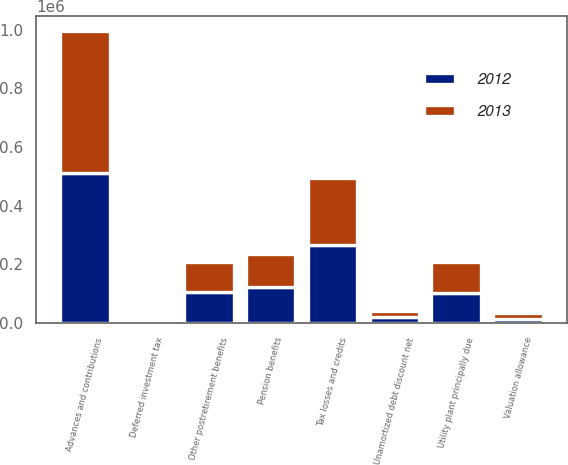<chart> <loc_0><loc_0><loc_500><loc_500><stacked_bar_chart><ecel><fcel>Advances and contributions<fcel>Deferred investment tax<fcel>Other postretirement benefits<fcel>Tax losses and credits<fcel>Pension benefits<fcel>Unamortized debt discount net<fcel>Valuation allowance<fcel>Utility plant principally due<nl><fcel>2012<fcel>510122<fcel>10027<fcel>107773<fcel>265640<fcel>122143<fcel>20249<fcel>13555<fcel>104037<nl><fcel>2013<fcel>485815<fcel>10610<fcel>100301<fcel>229423<fcel>113919<fcel>21711<fcel>19520<fcel>104037<nl></chart> 